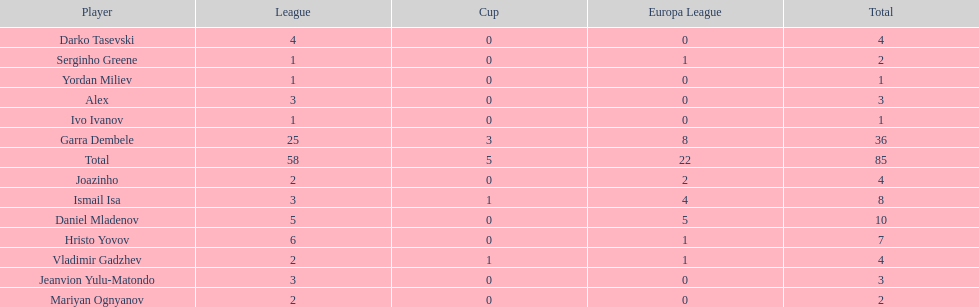Could you parse the entire table? {'header': ['Player', 'League', 'Cup', 'Europa League', 'Total'], 'rows': [['Darko Tasevski', '4', '0', '0', '4'], ['Serginho Greene', '1', '0', '1', '2'], ['Yordan Miliev', '1', '0', '0', '1'], ['Alex', '3', '0', '0', '3'], ['Ivo Ivanov', '1', '0', '0', '1'], ['Garra Dembele', '25', '3', '8', '36'], ['Total', '58', '5', '22', '85'], ['Joazinho', '2', '0', '2', '4'], ['Ismail Isa', '3', '1', '4', '8'], ['Daniel Mladenov', '5', '0', '5', '10'], ['Hristo Yovov', '6', '0', '1', '7'], ['Vladimir Gadzhev', '2', '1', '1', '4'], ['Jeanvion Yulu-Matondo', '3', '0', '0', '3'], ['Mariyan Ognyanov', '2', '0', '0', '2']]} Which is the only player from germany? Jeanvion Yulu-Matondo. 